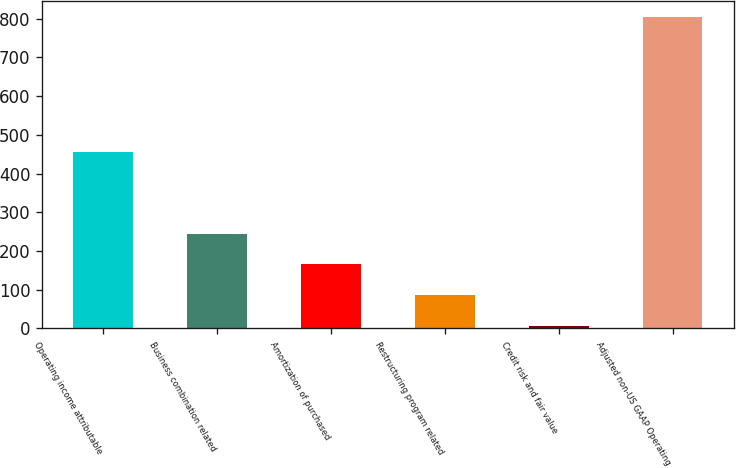<chart> <loc_0><loc_0><loc_500><loc_500><bar_chart><fcel>Operating income attributable<fcel>Business combination related<fcel>Amortization of purchased<fcel>Restructuring program related<fcel>Credit risk and fair value<fcel>Adjusted non-US GAAP Operating<nl><fcel>454.7<fcel>244.97<fcel>165.08<fcel>85.19<fcel>5.3<fcel>804.2<nl></chart> 